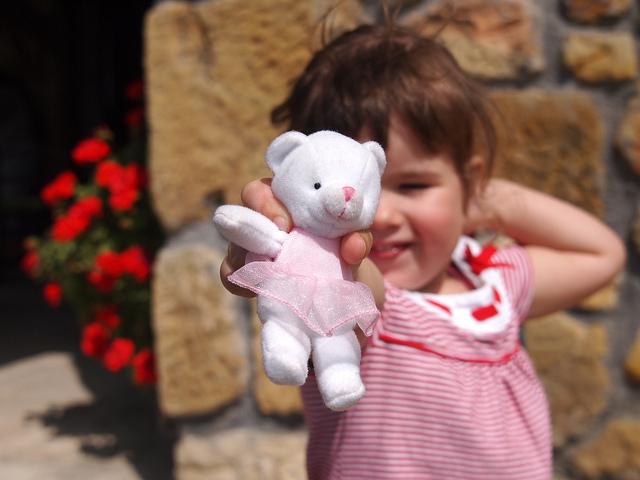What are the bears sitting on?
Short answer required. Nothing. What is she holding?
Keep it brief. Bear. What color is her dress?
Answer briefly. Red and white. What plant is in the background?
Quick response, please. Roses. How old is the bear?
Answer briefly. 1. 